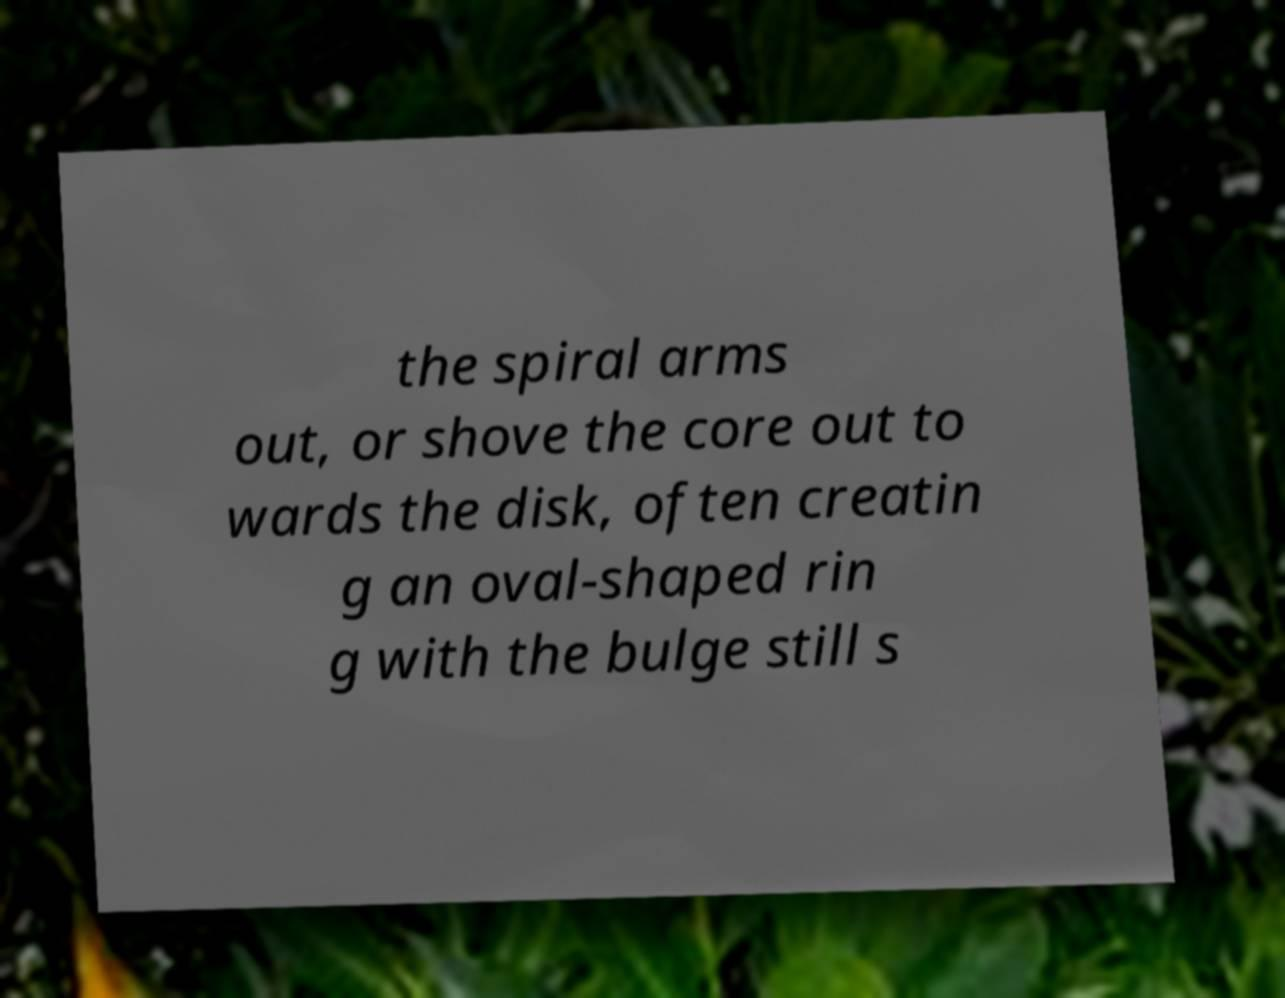Please read and relay the text visible in this image. What does it say? the spiral arms out, or shove the core out to wards the disk, often creatin g an oval-shaped rin g with the bulge still s 